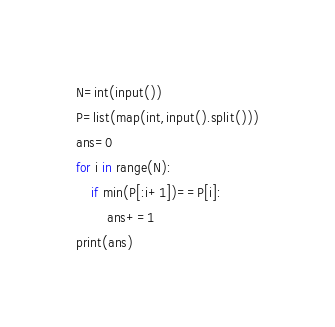<code> <loc_0><loc_0><loc_500><loc_500><_Python_>N=int(input())
P=list(map(int,input().split()))
ans=0
for i in range(N):
    if min(P[:i+1])==P[i]:
        ans+=1
print(ans)</code> 